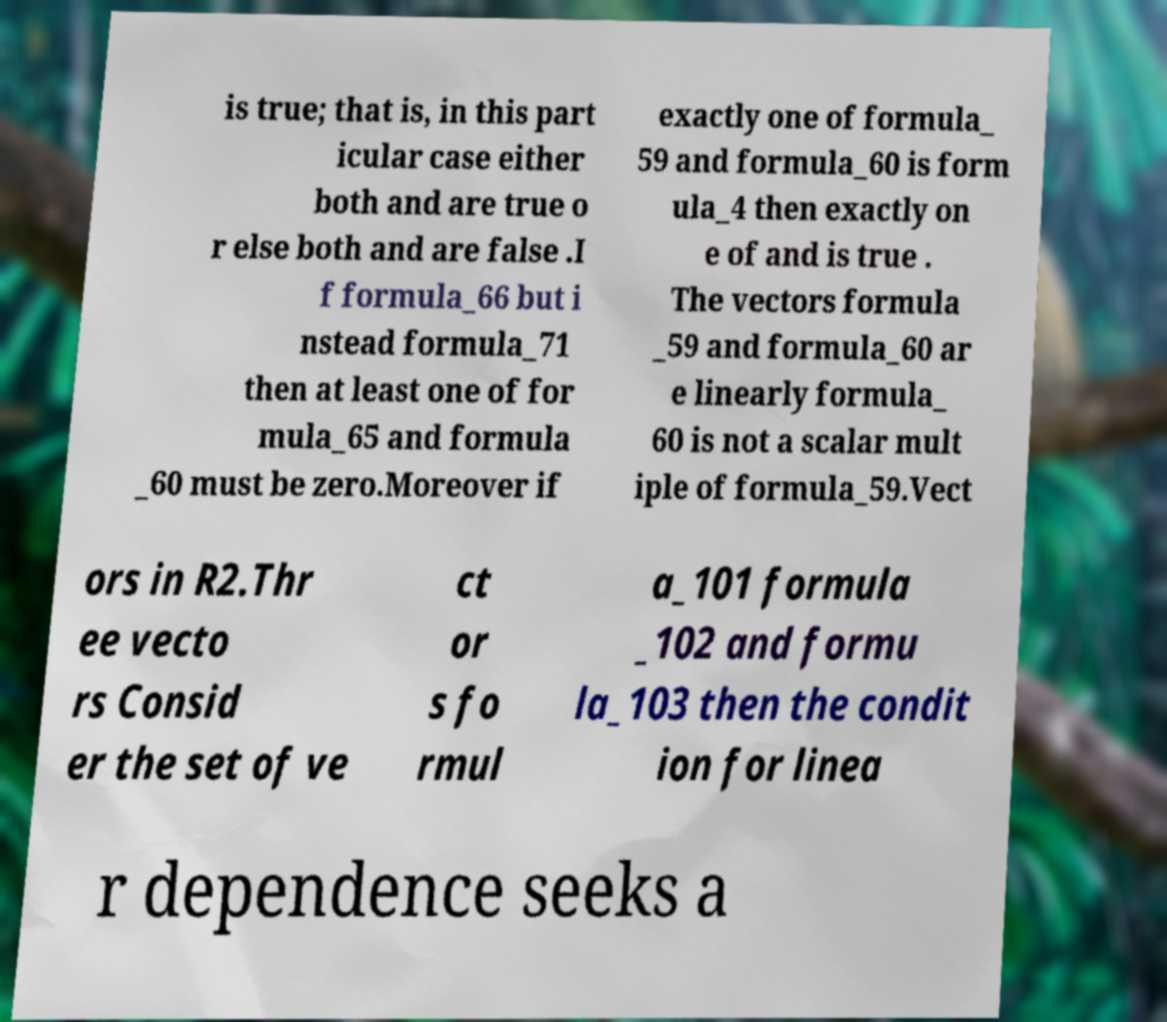Could you assist in decoding the text presented in this image and type it out clearly? is true; that is, in this part icular case either both and are true o r else both and are false .I f formula_66 but i nstead formula_71 then at least one of for mula_65 and formula _60 must be zero.Moreover if exactly one of formula_ 59 and formula_60 is form ula_4 then exactly on e of and is true . The vectors formula _59 and formula_60 ar e linearly formula_ 60 is not a scalar mult iple of formula_59.Vect ors in R2.Thr ee vecto rs Consid er the set of ve ct or s fo rmul a_101 formula _102 and formu la_103 then the condit ion for linea r dependence seeks a 